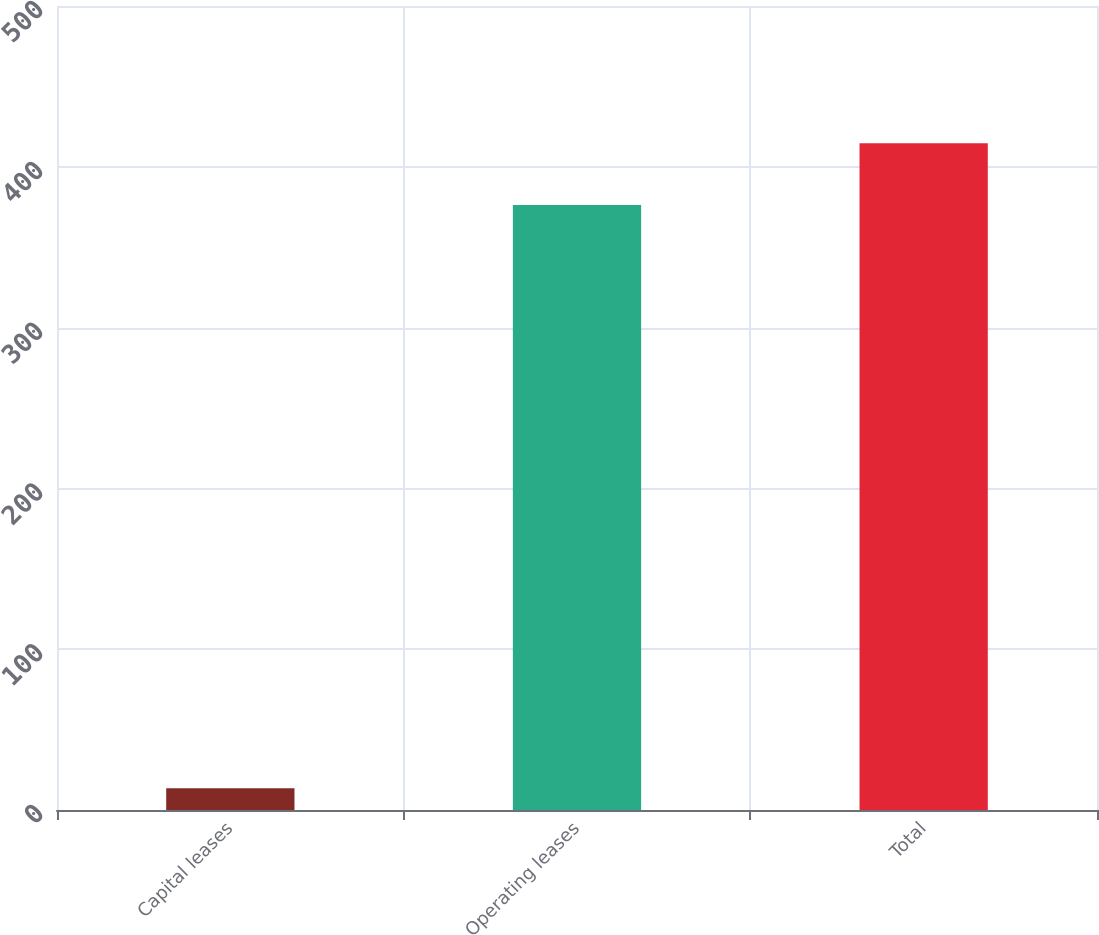Convert chart. <chart><loc_0><loc_0><loc_500><loc_500><bar_chart><fcel>Capital leases<fcel>Operating leases<fcel>Total<nl><fcel>13.6<fcel>376.2<fcel>414.71<nl></chart> 